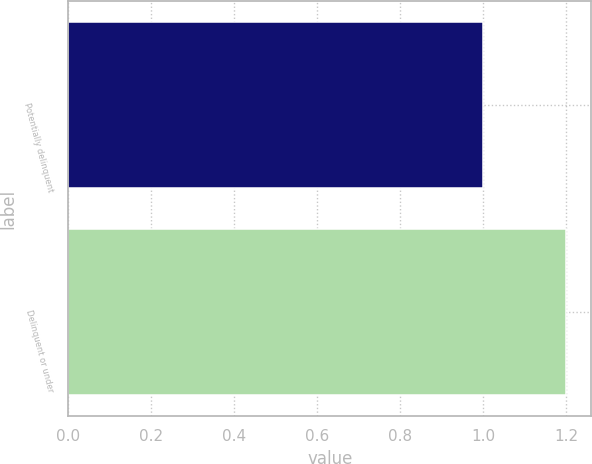<chart> <loc_0><loc_0><loc_500><loc_500><bar_chart><fcel>Potentially delinquent<fcel>Delinquent or under<nl><fcel>1<fcel>1.2<nl></chart> 